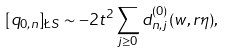Convert formula to latex. <formula><loc_0><loc_0><loc_500><loc_500>[ q _ { 0 , n } ] _ { \L S } \sim - 2 t ^ { 2 } \sum _ { j \geq 0 } d _ { n , j } ^ { ( 0 ) } ( w , r \eta ) ,</formula> 